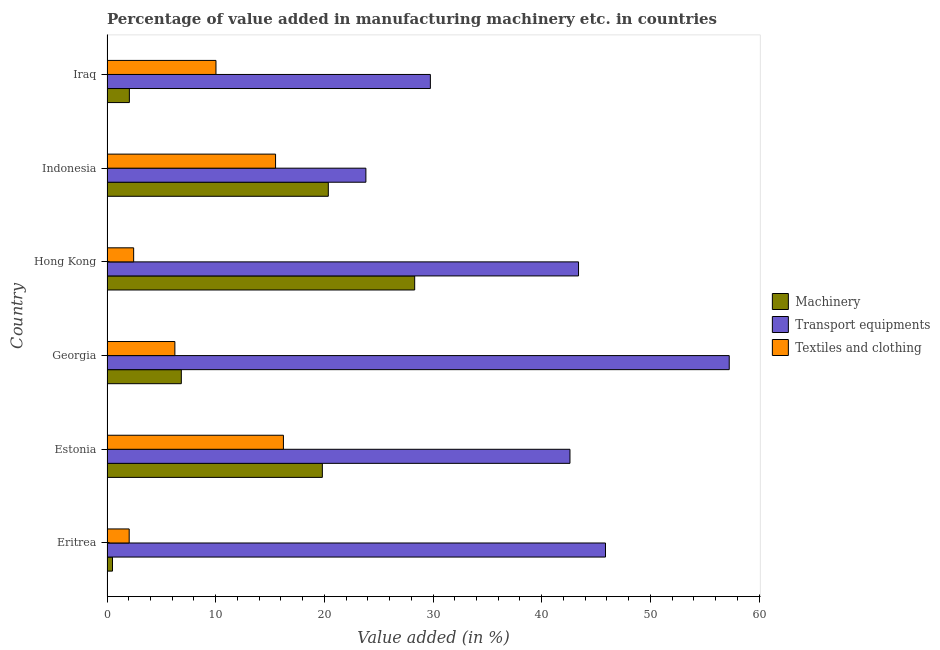How many different coloured bars are there?
Provide a succinct answer. 3. How many groups of bars are there?
Give a very brief answer. 6. How many bars are there on the 6th tick from the top?
Offer a very short reply. 3. What is the label of the 4th group of bars from the top?
Make the answer very short. Georgia. In how many cases, is the number of bars for a given country not equal to the number of legend labels?
Ensure brevity in your answer.  0. What is the value added in manufacturing textile and clothing in Estonia?
Offer a terse response. 16.23. Across all countries, what is the maximum value added in manufacturing transport equipments?
Make the answer very short. 57.26. Across all countries, what is the minimum value added in manufacturing textile and clothing?
Your response must be concise. 2.04. In which country was the value added in manufacturing machinery maximum?
Offer a very short reply. Hong Kong. In which country was the value added in manufacturing machinery minimum?
Ensure brevity in your answer.  Eritrea. What is the total value added in manufacturing textile and clothing in the graph?
Provide a succinct answer. 52.51. What is the difference between the value added in manufacturing machinery in Estonia and that in Hong Kong?
Make the answer very short. -8.5. What is the difference between the value added in manufacturing transport equipments in Eritrea and the value added in manufacturing machinery in Hong Kong?
Your answer should be compact. 17.56. What is the average value added in manufacturing machinery per country?
Ensure brevity in your answer.  12.98. What is the difference between the value added in manufacturing machinery and value added in manufacturing transport equipments in Iraq?
Give a very brief answer. -27.7. In how many countries, is the value added in manufacturing textile and clothing greater than 44 %?
Provide a short and direct response. 0. What is the ratio of the value added in manufacturing transport equipments in Hong Kong to that in Iraq?
Make the answer very short. 1.46. Is the value added in manufacturing transport equipments in Eritrea less than that in Estonia?
Your answer should be very brief. No. What is the difference between the highest and the second highest value added in manufacturing textile and clothing?
Ensure brevity in your answer.  0.72. What is the difference between the highest and the lowest value added in manufacturing machinery?
Your answer should be compact. 27.81. Is the sum of the value added in manufacturing textile and clothing in Eritrea and Indonesia greater than the maximum value added in manufacturing machinery across all countries?
Make the answer very short. No. What does the 2nd bar from the top in Hong Kong represents?
Your answer should be compact. Transport equipments. What does the 1st bar from the bottom in Indonesia represents?
Give a very brief answer. Machinery. Is it the case that in every country, the sum of the value added in manufacturing machinery and value added in manufacturing transport equipments is greater than the value added in manufacturing textile and clothing?
Your answer should be very brief. Yes. How many bars are there?
Provide a short and direct response. 18. Are all the bars in the graph horizontal?
Provide a succinct answer. Yes. What is the difference between two consecutive major ticks on the X-axis?
Provide a succinct answer. 10. What is the title of the graph?
Keep it short and to the point. Percentage of value added in manufacturing machinery etc. in countries. Does "Taxes" appear as one of the legend labels in the graph?
Offer a very short reply. No. What is the label or title of the X-axis?
Provide a succinct answer. Value added (in %). What is the label or title of the Y-axis?
Your answer should be very brief. Country. What is the Value added (in %) in Machinery in Eritrea?
Provide a succinct answer. 0.51. What is the Value added (in %) of Transport equipments in Eritrea?
Your answer should be very brief. 45.87. What is the Value added (in %) in Textiles and clothing in Eritrea?
Ensure brevity in your answer.  2.04. What is the Value added (in %) in Machinery in Estonia?
Ensure brevity in your answer.  19.82. What is the Value added (in %) in Transport equipments in Estonia?
Make the answer very short. 42.6. What is the Value added (in %) in Textiles and clothing in Estonia?
Give a very brief answer. 16.23. What is the Value added (in %) in Machinery in Georgia?
Make the answer very short. 6.84. What is the Value added (in %) of Transport equipments in Georgia?
Offer a terse response. 57.26. What is the Value added (in %) in Textiles and clothing in Georgia?
Give a very brief answer. 6.25. What is the Value added (in %) in Machinery in Hong Kong?
Provide a short and direct response. 28.31. What is the Value added (in %) in Transport equipments in Hong Kong?
Offer a terse response. 43.39. What is the Value added (in %) of Textiles and clothing in Hong Kong?
Provide a short and direct response. 2.45. What is the Value added (in %) of Machinery in Indonesia?
Keep it short and to the point. 20.37. What is the Value added (in %) in Transport equipments in Indonesia?
Give a very brief answer. 23.82. What is the Value added (in %) of Textiles and clothing in Indonesia?
Make the answer very short. 15.51. What is the Value added (in %) in Machinery in Iraq?
Provide a short and direct response. 2.06. What is the Value added (in %) of Transport equipments in Iraq?
Your response must be concise. 29.76. What is the Value added (in %) in Textiles and clothing in Iraq?
Ensure brevity in your answer.  10.03. Across all countries, what is the maximum Value added (in %) in Machinery?
Provide a succinct answer. 28.31. Across all countries, what is the maximum Value added (in %) in Transport equipments?
Give a very brief answer. 57.26. Across all countries, what is the maximum Value added (in %) of Textiles and clothing?
Your response must be concise. 16.23. Across all countries, what is the minimum Value added (in %) of Machinery?
Offer a very short reply. 0.51. Across all countries, what is the minimum Value added (in %) of Transport equipments?
Provide a short and direct response. 23.82. Across all countries, what is the minimum Value added (in %) of Textiles and clothing?
Offer a terse response. 2.04. What is the total Value added (in %) of Machinery in the graph?
Your answer should be compact. 77.9. What is the total Value added (in %) of Transport equipments in the graph?
Make the answer very short. 242.71. What is the total Value added (in %) in Textiles and clothing in the graph?
Ensure brevity in your answer.  52.51. What is the difference between the Value added (in %) of Machinery in Eritrea and that in Estonia?
Ensure brevity in your answer.  -19.31. What is the difference between the Value added (in %) of Transport equipments in Eritrea and that in Estonia?
Your answer should be compact. 3.27. What is the difference between the Value added (in %) of Textiles and clothing in Eritrea and that in Estonia?
Provide a short and direct response. -14.19. What is the difference between the Value added (in %) in Machinery in Eritrea and that in Georgia?
Provide a succinct answer. -6.33. What is the difference between the Value added (in %) in Transport equipments in Eritrea and that in Georgia?
Offer a very short reply. -11.39. What is the difference between the Value added (in %) of Textiles and clothing in Eritrea and that in Georgia?
Give a very brief answer. -4.2. What is the difference between the Value added (in %) of Machinery in Eritrea and that in Hong Kong?
Ensure brevity in your answer.  -27.81. What is the difference between the Value added (in %) in Transport equipments in Eritrea and that in Hong Kong?
Your response must be concise. 2.48. What is the difference between the Value added (in %) in Textiles and clothing in Eritrea and that in Hong Kong?
Ensure brevity in your answer.  -0.41. What is the difference between the Value added (in %) of Machinery in Eritrea and that in Indonesia?
Offer a terse response. -19.86. What is the difference between the Value added (in %) in Transport equipments in Eritrea and that in Indonesia?
Provide a succinct answer. 22.05. What is the difference between the Value added (in %) of Textiles and clothing in Eritrea and that in Indonesia?
Provide a succinct answer. -13.47. What is the difference between the Value added (in %) in Machinery in Eritrea and that in Iraq?
Make the answer very short. -1.55. What is the difference between the Value added (in %) of Transport equipments in Eritrea and that in Iraq?
Give a very brief answer. 16.12. What is the difference between the Value added (in %) in Textiles and clothing in Eritrea and that in Iraq?
Offer a terse response. -7.99. What is the difference between the Value added (in %) of Machinery in Estonia and that in Georgia?
Your response must be concise. 12.98. What is the difference between the Value added (in %) of Transport equipments in Estonia and that in Georgia?
Your response must be concise. -14.66. What is the difference between the Value added (in %) of Textiles and clothing in Estonia and that in Georgia?
Your answer should be compact. 9.99. What is the difference between the Value added (in %) of Machinery in Estonia and that in Hong Kong?
Your answer should be compact. -8.5. What is the difference between the Value added (in %) of Transport equipments in Estonia and that in Hong Kong?
Ensure brevity in your answer.  -0.79. What is the difference between the Value added (in %) of Textiles and clothing in Estonia and that in Hong Kong?
Your answer should be very brief. 13.78. What is the difference between the Value added (in %) of Machinery in Estonia and that in Indonesia?
Provide a short and direct response. -0.55. What is the difference between the Value added (in %) of Transport equipments in Estonia and that in Indonesia?
Your response must be concise. 18.78. What is the difference between the Value added (in %) in Textiles and clothing in Estonia and that in Indonesia?
Make the answer very short. 0.72. What is the difference between the Value added (in %) of Machinery in Estonia and that in Iraq?
Make the answer very short. 17.76. What is the difference between the Value added (in %) of Transport equipments in Estonia and that in Iraq?
Your answer should be very brief. 12.85. What is the difference between the Value added (in %) of Textiles and clothing in Estonia and that in Iraq?
Provide a short and direct response. 6.21. What is the difference between the Value added (in %) in Machinery in Georgia and that in Hong Kong?
Make the answer very short. -21.48. What is the difference between the Value added (in %) in Transport equipments in Georgia and that in Hong Kong?
Keep it short and to the point. 13.87. What is the difference between the Value added (in %) in Textiles and clothing in Georgia and that in Hong Kong?
Keep it short and to the point. 3.79. What is the difference between the Value added (in %) in Machinery in Georgia and that in Indonesia?
Offer a terse response. -13.53. What is the difference between the Value added (in %) in Transport equipments in Georgia and that in Indonesia?
Your answer should be very brief. 33.44. What is the difference between the Value added (in %) in Textiles and clothing in Georgia and that in Indonesia?
Your answer should be very brief. -9.26. What is the difference between the Value added (in %) in Machinery in Georgia and that in Iraq?
Your answer should be very brief. 4.78. What is the difference between the Value added (in %) in Transport equipments in Georgia and that in Iraq?
Provide a succinct answer. 27.5. What is the difference between the Value added (in %) of Textiles and clothing in Georgia and that in Iraq?
Make the answer very short. -3.78. What is the difference between the Value added (in %) of Machinery in Hong Kong and that in Indonesia?
Offer a very short reply. 7.95. What is the difference between the Value added (in %) of Transport equipments in Hong Kong and that in Indonesia?
Provide a short and direct response. 19.57. What is the difference between the Value added (in %) of Textiles and clothing in Hong Kong and that in Indonesia?
Your answer should be compact. -13.06. What is the difference between the Value added (in %) of Machinery in Hong Kong and that in Iraq?
Offer a very short reply. 26.26. What is the difference between the Value added (in %) in Transport equipments in Hong Kong and that in Iraq?
Make the answer very short. 13.63. What is the difference between the Value added (in %) in Textiles and clothing in Hong Kong and that in Iraq?
Provide a succinct answer. -7.57. What is the difference between the Value added (in %) of Machinery in Indonesia and that in Iraq?
Your answer should be very brief. 18.31. What is the difference between the Value added (in %) in Transport equipments in Indonesia and that in Iraq?
Make the answer very short. -5.93. What is the difference between the Value added (in %) in Textiles and clothing in Indonesia and that in Iraq?
Offer a very short reply. 5.48. What is the difference between the Value added (in %) in Machinery in Eritrea and the Value added (in %) in Transport equipments in Estonia?
Your answer should be compact. -42.1. What is the difference between the Value added (in %) of Machinery in Eritrea and the Value added (in %) of Textiles and clothing in Estonia?
Make the answer very short. -15.73. What is the difference between the Value added (in %) in Transport equipments in Eritrea and the Value added (in %) in Textiles and clothing in Estonia?
Your answer should be very brief. 29.64. What is the difference between the Value added (in %) in Machinery in Eritrea and the Value added (in %) in Transport equipments in Georgia?
Provide a short and direct response. -56.75. What is the difference between the Value added (in %) in Machinery in Eritrea and the Value added (in %) in Textiles and clothing in Georgia?
Your response must be concise. -5.74. What is the difference between the Value added (in %) in Transport equipments in Eritrea and the Value added (in %) in Textiles and clothing in Georgia?
Offer a terse response. 39.63. What is the difference between the Value added (in %) of Machinery in Eritrea and the Value added (in %) of Transport equipments in Hong Kong?
Offer a terse response. -42.89. What is the difference between the Value added (in %) of Machinery in Eritrea and the Value added (in %) of Textiles and clothing in Hong Kong?
Ensure brevity in your answer.  -1.95. What is the difference between the Value added (in %) in Transport equipments in Eritrea and the Value added (in %) in Textiles and clothing in Hong Kong?
Give a very brief answer. 43.42. What is the difference between the Value added (in %) of Machinery in Eritrea and the Value added (in %) of Transport equipments in Indonesia?
Offer a very short reply. -23.32. What is the difference between the Value added (in %) of Machinery in Eritrea and the Value added (in %) of Textiles and clothing in Indonesia?
Ensure brevity in your answer.  -15.01. What is the difference between the Value added (in %) in Transport equipments in Eritrea and the Value added (in %) in Textiles and clothing in Indonesia?
Provide a short and direct response. 30.36. What is the difference between the Value added (in %) in Machinery in Eritrea and the Value added (in %) in Transport equipments in Iraq?
Keep it short and to the point. -29.25. What is the difference between the Value added (in %) in Machinery in Eritrea and the Value added (in %) in Textiles and clothing in Iraq?
Provide a succinct answer. -9.52. What is the difference between the Value added (in %) of Transport equipments in Eritrea and the Value added (in %) of Textiles and clothing in Iraq?
Offer a terse response. 35.85. What is the difference between the Value added (in %) of Machinery in Estonia and the Value added (in %) of Transport equipments in Georgia?
Make the answer very short. -37.44. What is the difference between the Value added (in %) of Machinery in Estonia and the Value added (in %) of Textiles and clothing in Georgia?
Your response must be concise. 13.57. What is the difference between the Value added (in %) of Transport equipments in Estonia and the Value added (in %) of Textiles and clothing in Georgia?
Offer a very short reply. 36.36. What is the difference between the Value added (in %) of Machinery in Estonia and the Value added (in %) of Transport equipments in Hong Kong?
Ensure brevity in your answer.  -23.57. What is the difference between the Value added (in %) of Machinery in Estonia and the Value added (in %) of Textiles and clothing in Hong Kong?
Provide a short and direct response. 17.36. What is the difference between the Value added (in %) in Transport equipments in Estonia and the Value added (in %) in Textiles and clothing in Hong Kong?
Give a very brief answer. 40.15. What is the difference between the Value added (in %) in Machinery in Estonia and the Value added (in %) in Transport equipments in Indonesia?
Make the answer very short. -4.01. What is the difference between the Value added (in %) of Machinery in Estonia and the Value added (in %) of Textiles and clothing in Indonesia?
Your answer should be very brief. 4.31. What is the difference between the Value added (in %) of Transport equipments in Estonia and the Value added (in %) of Textiles and clothing in Indonesia?
Make the answer very short. 27.09. What is the difference between the Value added (in %) in Machinery in Estonia and the Value added (in %) in Transport equipments in Iraq?
Offer a terse response. -9.94. What is the difference between the Value added (in %) in Machinery in Estonia and the Value added (in %) in Textiles and clothing in Iraq?
Your answer should be compact. 9.79. What is the difference between the Value added (in %) of Transport equipments in Estonia and the Value added (in %) of Textiles and clothing in Iraq?
Make the answer very short. 32.58. What is the difference between the Value added (in %) in Machinery in Georgia and the Value added (in %) in Transport equipments in Hong Kong?
Ensure brevity in your answer.  -36.55. What is the difference between the Value added (in %) in Machinery in Georgia and the Value added (in %) in Textiles and clothing in Hong Kong?
Keep it short and to the point. 4.39. What is the difference between the Value added (in %) in Transport equipments in Georgia and the Value added (in %) in Textiles and clothing in Hong Kong?
Your answer should be compact. 54.81. What is the difference between the Value added (in %) of Machinery in Georgia and the Value added (in %) of Transport equipments in Indonesia?
Give a very brief answer. -16.98. What is the difference between the Value added (in %) in Machinery in Georgia and the Value added (in %) in Textiles and clothing in Indonesia?
Offer a very short reply. -8.67. What is the difference between the Value added (in %) of Transport equipments in Georgia and the Value added (in %) of Textiles and clothing in Indonesia?
Your response must be concise. 41.75. What is the difference between the Value added (in %) in Machinery in Georgia and the Value added (in %) in Transport equipments in Iraq?
Ensure brevity in your answer.  -22.92. What is the difference between the Value added (in %) in Machinery in Georgia and the Value added (in %) in Textiles and clothing in Iraq?
Ensure brevity in your answer.  -3.19. What is the difference between the Value added (in %) in Transport equipments in Georgia and the Value added (in %) in Textiles and clothing in Iraq?
Provide a succinct answer. 47.23. What is the difference between the Value added (in %) of Machinery in Hong Kong and the Value added (in %) of Transport equipments in Indonesia?
Keep it short and to the point. 4.49. What is the difference between the Value added (in %) in Machinery in Hong Kong and the Value added (in %) in Textiles and clothing in Indonesia?
Provide a short and direct response. 12.8. What is the difference between the Value added (in %) of Transport equipments in Hong Kong and the Value added (in %) of Textiles and clothing in Indonesia?
Provide a succinct answer. 27.88. What is the difference between the Value added (in %) in Machinery in Hong Kong and the Value added (in %) in Transport equipments in Iraq?
Offer a terse response. -1.44. What is the difference between the Value added (in %) of Machinery in Hong Kong and the Value added (in %) of Textiles and clothing in Iraq?
Provide a succinct answer. 18.29. What is the difference between the Value added (in %) of Transport equipments in Hong Kong and the Value added (in %) of Textiles and clothing in Iraq?
Your response must be concise. 33.36. What is the difference between the Value added (in %) in Machinery in Indonesia and the Value added (in %) in Transport equipments in Iraq?
Provide a short and direct response. -9.39. What is the difference between the Value added (in %) in Machinery in Indonesia and the Value added (in %) in Textiles and clothing in Iraq?
Give a very brief answer. 10.34. What is the difference between the Value added (in %) in Transport equipments in Indonesia and the Value added (in %) in Textiles and clothing in Iraq?
Your answer should be compact. 13.8. What is the average Value added (in %) of Machinery per country?
Ensure brevity in your answer.  12.98. What is the average Value added (in %) in Transport equipments per country?
Offer a terse response. 40.45. What is the average Value added (in %) of Textiles and clothing per country?
Ensure brevity in your answer.  8.75. What is the difference between the Value added (in %) in Machinery and Value added (in %) in Transport equipments in Eritrea?
Your answer should be very brief. -45.37. What is the difference between the Value added (in %) in Machinery and Value added (in %) in Textiles and clothing in Eritrea?
Your answer should be compact. -1.54. What is the difference between the Value added (in %) in Transport equipments and Value added (in %) in Textiles and clothing in Eritrea?
Offer a very short reply. 43.83. What is the difference between the Value added (in %) in Machinery and Value added (in %) in Transport equipments in Estonia?
Your answer should be very brief. -22.79. What is the difference between the Value added (in %) in Machinery and Value added (in %) in Textiles and clothing in Estonia?
Keep it short and to the point. 3.58. What is the difference between the Value added (in %) in Transport equipments and Value added (in %) in Textiles and clothing in Estonia?
Offer a terse response. 26.37. What is the difference between the Value added (in %) in Machinery and Value added (in %) in Transport equipments in Georgia?
Give a very brief answer. -50.42. What is the difference between the Value added (in %) of Machinery and Value added (in %) of Textiles and clothing in Georgia?
Keep it short and to the point. 0.59. What is the difference between the Value added (in %) in Transport equipments and Value added (in %) in Textiles and clothing in Georgia?
Offer a terse response. 51.01. What is the difference between the Value added (in %) of Machinery and Value added (in %) of Transport equipments in Hong Kong?
Offer a very short reply. -15.08. What is the difference between the Value added (in %) of Machinery and Value added (in %) of Textiles and clothing in Hong Kong?
Offer a very short reply. 25.86. What is the difference between the Value added (in %) of Transport equipments and Value added (in %) of Textiles and clothing in Hong Kong?
Make the answer very short. 40.94. What is the difference between the Value added (in %) in Machinery and Value added (in %) in Transport equipments in Indonesia?
Your response must be concise. -3.46. What is the difference between the Value added (in %) in Machinery and Value added (in %) in Textiles and clothing in Indonesia?
Keep it short and to the point. 4.86. What is the difference between the Value added (in %) in Transport equipments and Value added (in %) in Textiles and clothing in Indonesia?
Your response must be concise. 8.31. What is the difference between the Value added (in %) in Machinery and Value added (in %) in Transport equipments in Iraq?
Provide a succinct answer. -27.7. What is the difference between the Value added (in %) of Machinery and Value added (in %) of Textiles and clothing in Iraq?
Make the answer very short. -7.97. What is the difference between the Value added (in %) of Transport equipments and Value added (in %) of Textiles and clothing in Iraq?
Offer a very short reply. 19.73. What is the ratio of the Value added (in %) of Machinery in Eritrea to that in Estonia?
Keep it short and to the point. 0.03. What is the ratio of the Value added (in %) of Transport equipments in Eritrea to that in Estonia?
Your answer should be very brief. 1.08. What is the ratio of the Value added (in %) of Textiles and clothing in Eritrea to that in Estonia?
Offer a terse response. 0.13. What is the ratio of the Value added (in %) of Machinery in Eritrea to that in Georgia?
Offer a very short reply. 0.07. What is the ratio of the Value added (in %) in Transport equipments in Eritrea to that in Georgia?
Your response must be concise. 0.8. What is the ratio of the Value added (in %) in Textiles and clothing in Eritrea to that in Georgia?
Make the answer very short. 0.33. What is the ratio of the Value added (in %) in Machinery in Eritrea to that in Hong Kong?
Keep it short and to the point. 0.02. What is the ratio of the Value added (in %) in Transport equipments in Eritrea to that in Hong Kong?
Keep it short and to the point. 1.06. What is the ratio of the Value added (in %) of Textiles and clothing in Eritrea to that in Hong Kong?
Offer a terse response. 0.83. What is the ratio of the Value added (in %) of Machinery in Eritrea to that in Indonesia?
Provide a succinct answer. 0.02. What is the ratio of the Value added (in %) of Transport equipments in Eritrea to that in Indonesia?
Keep it short and to the point. 1.93. What is the ratio of the Value added (in %) in Textiles and clothing in Eritrea to that in Indonesia?
Give a very brief answer. 0.13. What is the ratio of the Value added (in %) of Machinery in Eritrea to that in Iraq?
Ensure brevity in your answer.  0.25. What is the ratio of the Value added (in %) of Transport equipments in Eritrea to that in Iraq?
Provide a succinct answer. 1.54. What is the ratio of the Value added (in %) of Textiles and clothing in Eritrea to that in Iraq?
Your answer should be compact. 0.2. What is the ratio of the Value added (in %) in Machinery in Estonia to that in Georgia?
Your answer should be compact. 2.9. What is the ratio of the Value added (in %) in Transport equipments in Estonia to that in Georgia?
Ensure brevity in your answer.  0.74. What is the ratio of the Value added (in %) in Textiles and clothing in Estonia to that in Georgia?
Offer a terse response. 2.6. What is the ratio of the Value added (in %) of Machinery in Estonia to that in Hong Kong?
Give a very brief answer. 0.7. What is the ratio of the Value added (in %) in Transport equipments in Estonia to that in Hong Kong?
Provide a succinct answer. 0.98. What is the ratio of the Value added (in %) in Textiles and clothing in Estonia to that in Hong Kong?
Provide a succinct answer. 6.62. What is the ratio of the Value added (in %) of Machinery in Estonia to that in Indonesia?
Ensure brevity in your answer.  0.97. What is the ratio of the Value added (in %) in Transport equipments in Estonia to that in Indonesia?
Offer a terse response. 1.79. What is the ratio of the Value added (in %) of Textiles and clothing in Estonia to that in Indonesia?
Your answer should be very brief. 1.05. What is the ratio of the Value added (in %) of Machinery in Estonia to that in Iraq?
Offer a very short reply. 9.63. What is the ratio of the Value added (in %) of Transport equipments in Estonia to that in Iraq?
Offer a very short reply. 1.43. What is the ratio of the Value added (in %) in Textiles and clothing in Estonia to that in Iraq?
Offer a very short reply. 1.62. What is the ratio of the Value added (in %) of Machinery in Georgia to that in Hong Kong?
Keep it short and to the point. 0.24. What is the ratio of the Value added (in %) of Transport equipments in Georgia to that in Hong Kong?
Provide a short and direct response. 1.32. What is the ratio of the Value added (in %) in Textiles and clothing in Georgia to that in Hong Kong?
Provide a succinct answer. 2.55. What is the ratio of the Value added (in %) in Machinery in Georgia to that in Indonesia?
Provide a succinct answer. 0.34. What is the ratio of the Value added (in %) of Transport equipments in Georgia to that in Indonesia?
Your answer should be very brief. 2.4. What is the ratio of the Value added (in %) in Textiles and clothing in Georgia to that in Indonesia?
Make the answer very short. 0.4. What is the ratio of the Value added (in %) in Machinery in Georgia to that in Iraq?
Your answer should be compact. 3.32. What is the ratio of the Value added (in %) in Transport equipments in Georgia to that in Iraq?
Offer a very short reply. 1.92. What is the ratio of the Value added (in %) in Textiles and clothing in Georgia to that in Iraq?
Offer a very short reply. 0.62. What is the ratio of the Value added (in %) in Machinery in Hong Kong to that in Indonesia?
Provide a short and direct response. 1.39. What is the ratio of the Value added (in %) of Transport equipments in Hong Kong to that in Indonesia?
Ensure brevity in your answer.  1.82. What is the ratio of the Value added (in %) of Textiles and clothing in Hong Kong to that in Indonesia?
Your answer should be very brief. 0.16. What is the ratio of the Value added (in %) in Machinery in Hong Kong to that in Iraq?
Your response must be concise. 13.76. What is the ratio of the Value added (in %) in Transport equipments in Hong Kong to that in Iraq?
Provide a short and direct response. 1.46. What is the ratio of the Value added (in %) of Textiles and clothing in Hong Kong to that in Iraq?
Offer a terse response. 0.24. What is the ratio of the Value added (in %) in Machinery in Indonesia to that in Iraq?
Keep it short and to the point. 9.89. What is the ratio of the Value added (in %) of Transport equipments in Indonesia to that in Iraq?
Your response must be concise. 0.8. What is the ratio of the Value added (in %) in Textiles and clothing in Indonesia to that in Iraq?
Provide a succinct answer. 1.55. What is the difference between the highest and the second highest Value added (in %) in Machinery?
Your response must be concise. 7.95. What is the difference between the highest and the second highest Value added (in %) of Transport equipments?
Your response must be concise. 11.39. What is the difference between the highest and the second highest Value added (in %) of Textiles and clothing?
Ensure brevity in your answer.  0.72. What is the difference between the highest and the lowest Value added (in %) of Machinery?
Your answer should be very brief. 27.81. What is the difference between the highest and the lowest Value added (in %) in Transport equipments?
Offer a very short reply. 33.44. What is the difference between the highest and the lowest Value added (in %) in Textiles and clothing?
Offer a very short reply. 14.19. 